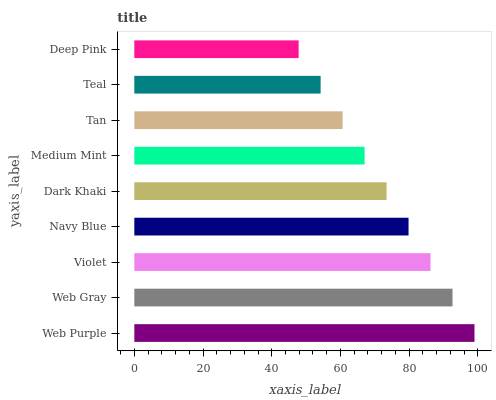Is Deep Pink the minimum?
Answer yes or no. Yes. Is Web Purple the maximum?
Answer yes or no. Yes. Is Web Gray the minimum?
Answer yes or no. No. Is Web Gray the maximum?
Answer yes or no. No. Is Web Purple greater than Web Gray?
Answer yes or no. Yes. Is Web Gray less than Web Purple?
Answer yes or no. Yes. Is Web Gray greater than Web Purple?
Answer yes or no. No. Is Web Purple less than Web Gray?
Answer yes or no. No. Is Dark Khaki the high median?
Answer yes or no. Yes. Is Dark Khaki the low median?
Answer yes or no. Yes. Is Web Gray the high median?
Answer yes or no. No. Is Web Gray the low median?
Answer yes or no. No. 